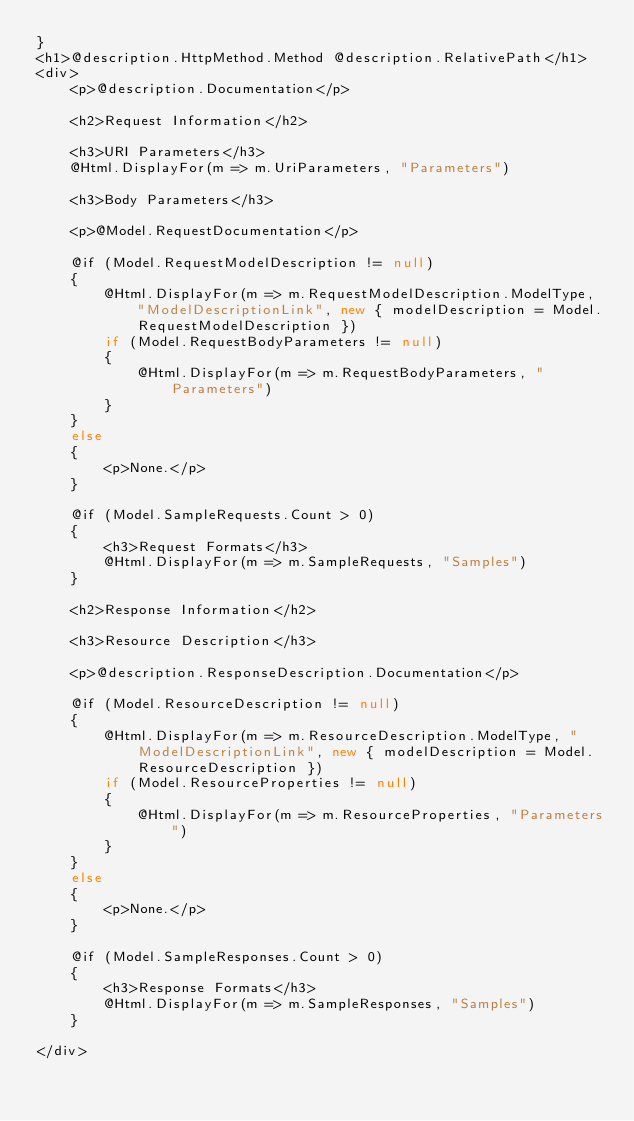<code> <loc_0><loc_0><loc_500><loc_500><_C#_>}
<h1>@description.HttpMethod.Method @description.RelativePath</h1>
<div>
    <p>@description.Documentation</p>

    <h2>Request Information</h2>

    <h3>URI Parameters</h3>
    @Html.DisplayFor(m => m.UriParameters, "Parameters")

    <h3>Body Parameters</h3>

    <p>@Model.RequestDocumentation</p>

    @if (Model.RequestModelDescription != null)
    {
        @Html.DisplayFor(m => m.RequestModelDescription.ModelType, "ModelDescriptionLink", new { modelDescription = Model.RequestModelDescription })
        if (Model.RequestBodyParameters != null)
        {
            @Html.DisplayFor(m => m.RequestBodyParameters, "Parameters")
        }
    }
    else
    {
        <p>None.</p>
    }

    @if (Model.SampleRequests.Count > 0)
    {
        <h3>Request Formats</h3>
        @Html.DisplayFor(m => m.SampleRequests, "Samples")
    }

    <h2>Response Information</h2>

    <h3>Resource Description</h3>

    <p>@description.ResponseDescription.Documentation</p>

    @if (Model.ResourceDescription != null)
    {
        @Html.DisplayFor(m => m.ResourceDescription.ModelType, "ModelDescriptionLink", new { modelDescription = Model.ResourceDescription })
        if (Model.ResourceProperties != null)
        {
            @Html.DisplayFor(m => m.ResourceProperties, "Parameters")
        }
    }
    else
    {
        <p>None.</p>
    }

    @if (Model.SampleResponses.Count > 0)
    {
        <h3>Response Formats</h3>
        @Html.DisplayFor(m => m.SampleResponses, "Samples")
    }

</div></code> 